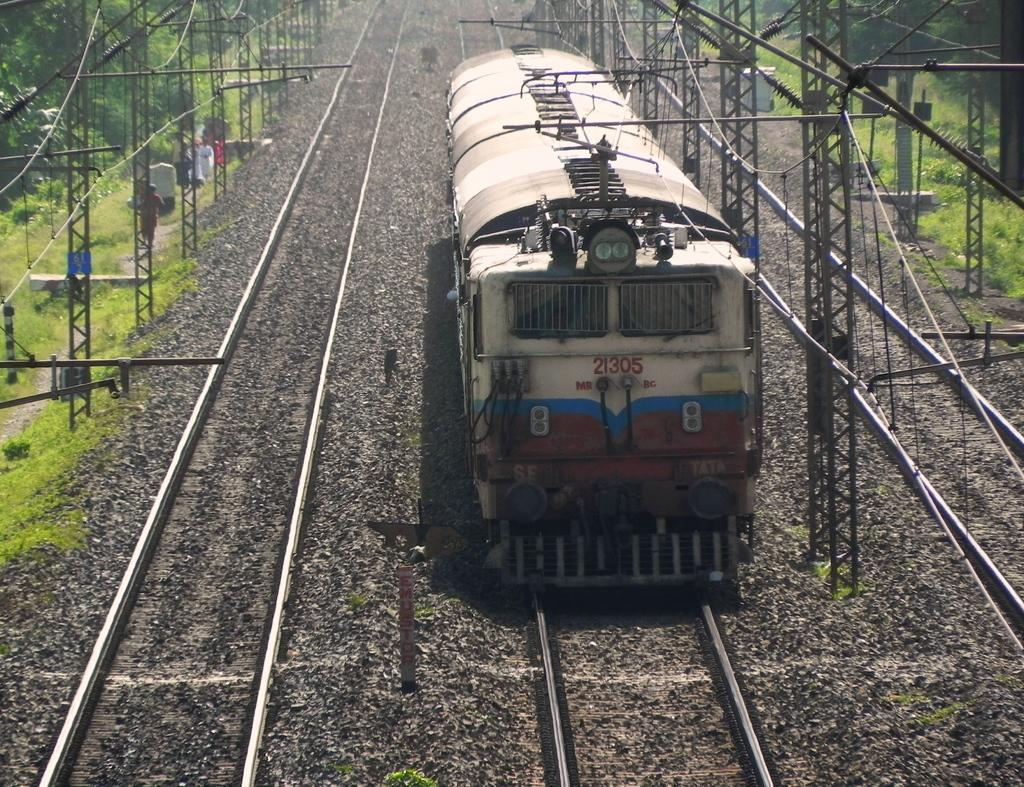What is the main subject of the image? The main subject of the image is a train. Can you describe the train's position in the image? The train is on a track in the image. What can be seen in the background of the image? There are poles and trees in the background of the image. What type of chin does the father have in the image? There is no father or chin present in the image; it features a train on a track with poles and trees in the background. 